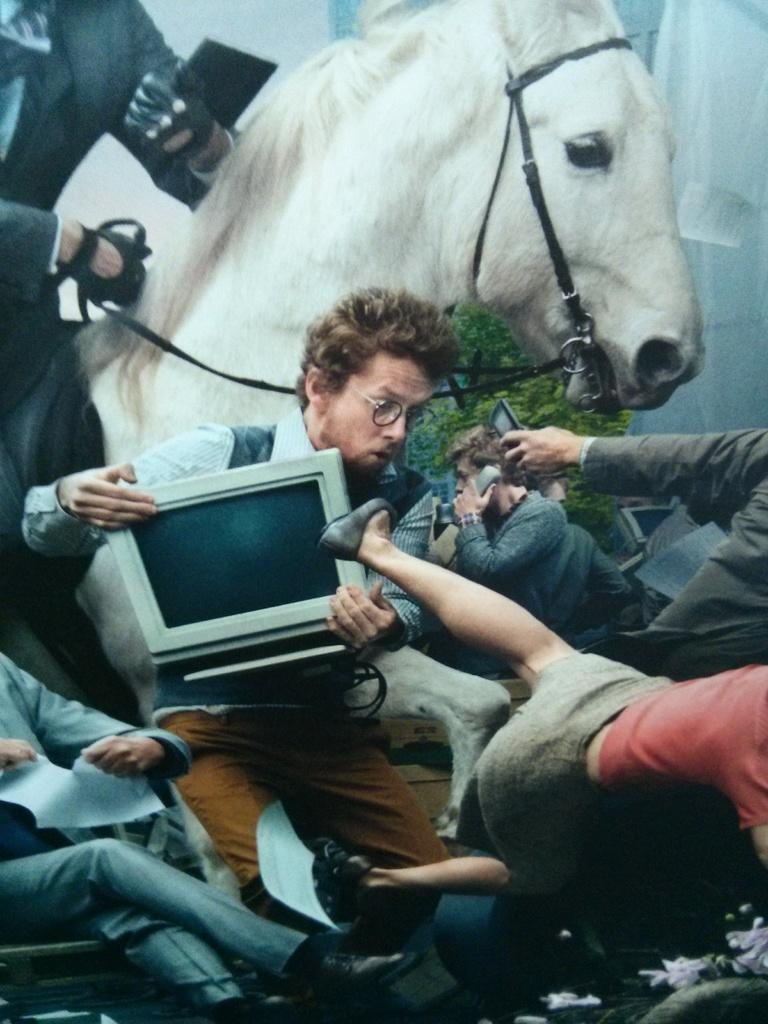Who or what can be seen in the image? There are people and a horse in the image. What is the position of the person sitting on a chair? One person is sitting on a chair in the image. What else can be seen in the image besides people and a horse? There is a plant in the image. What are the other people doing in the image? Other people are holding objects. What color is the crayon being used by the person holding it in the image? There is no crayon present in the image. What is the opinion of the horse about the objects being held by the people in the image? The image does not provide any information about the horse's opinion on the objects being held by the people. 